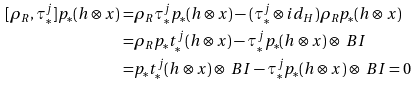<formula> <loc_0><loc_0><loc_500><loc_500>[ \rho _ { R } , \tau _ { * } ^ { j } ] p _ { * } ( { h } \otimes x ) = & \rho _ { R } \tau _ { * } ^ { j } p _ { * } ( { h } \otimes x ) - ( \tau _ { * } ^ { j } \otimes i d _ { H } ) \rho _ { R } p _ { * } ( { h } \otimes x ) \\ = & \rho _ { R } p _ { * } t _ { * } ^ { j } ( { h } \otimes x ) - \tau _ { * } ^ { j } p _ { * } ( { h } \otimes x ) \otimes \ B { I } \\ = & p _ { * } t _ { * } ^ { j } ( { h } \otimes x ) \otimes \ B { I } - \tau _ { * } ^ { j } p _ { * } ( { h } \otimes x ) \otimes \ B { I } = 0</formula> 